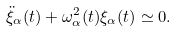<formula> <loc_0><loc_0><loc_500><loc_500>\ddot { \xi } _ { \alpha } ( t ) + \omega _ { \alpha } ^ { 2 } ( t ) \xi _ { \alpha } ( t ) \simeq 0 .</formula> 